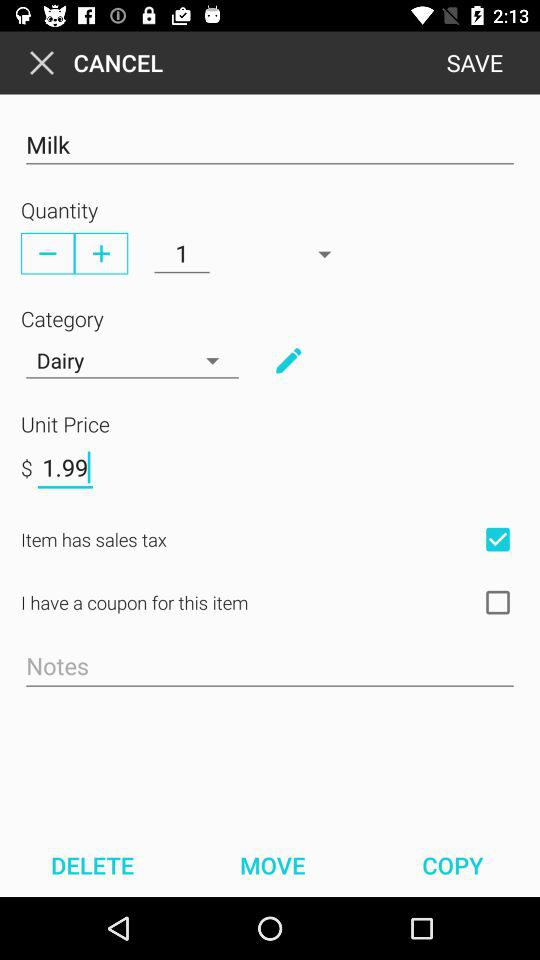What is the category of the product? The category of the product is "Dairy". 